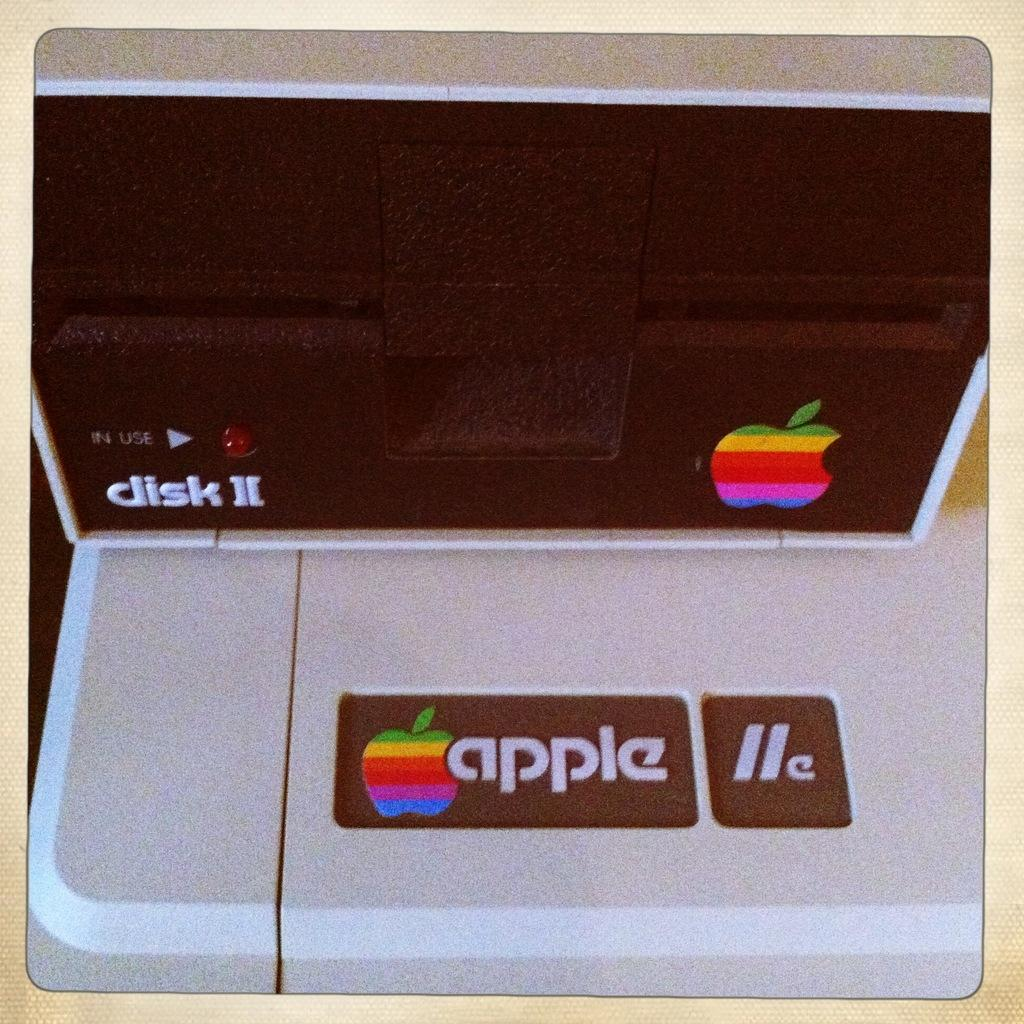<image>
Render a clear and concise summary of the photo. An antique Apple Disk II machine sits on a table. 